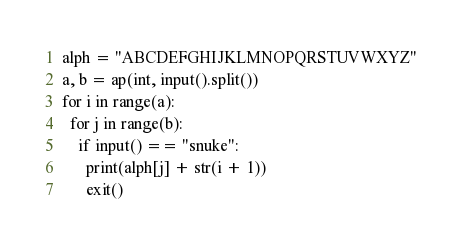<code> <loc_0><loc_0><loc_500><loc_500><_Python_>alph = "ABCDEFGHIJKLMNOPQRSTUVWXYZ"
a, b = ap(int, input().split())
for i in range(a):
  for j in range(b):
    if input() == "snuke":
      print(alph[j] + str(i + 1))
      exit()</code> 